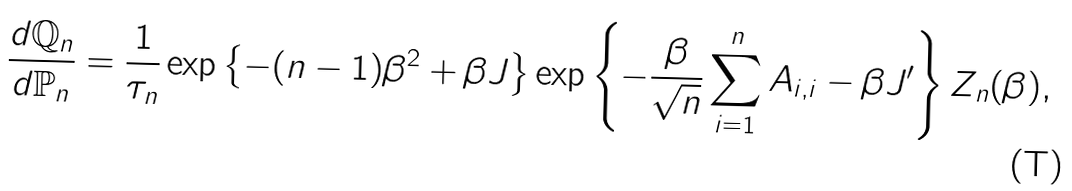<formula> <loc_0><loc_0><loc_500><loc_500>\frac { d \mathbb { Q } _ { n } } { d \mathbb { P } _ { n } } = \frac { 1 } { \tau _ { n } } \exp \left \{ - ( n - 1 ) \beta ^ { 2 } + \beta J \right \} \exp \left \{ - \frac { \beta } { \sqrt { n } } \sum _ { i = 1 } ^ { n } A _ { i , i } - \beta J ^ { \prime } \right \} Z _ { n } ( \beta ) ,</formula> 